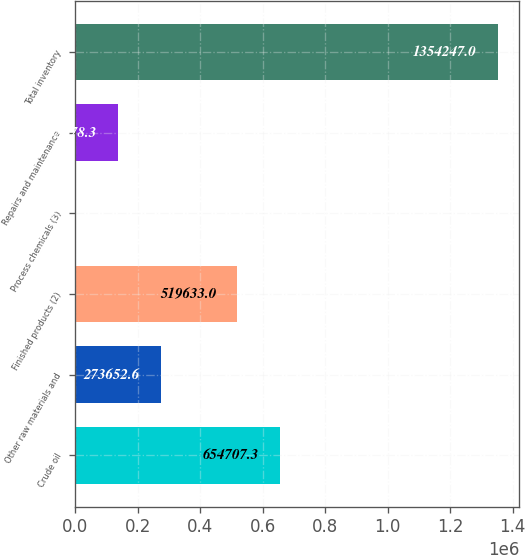Convert chart to OTSL. <chart><loc_0><loc_0><loc_500><loc_500><bar_chart><fcel>Crude oil<fcel>Other raw materials and<fcel>Finished products (2)<fcel>Process chemicals (3)<fcel>Repairs and maintenance<fcel>Total inventory<nl><fcel>654707<fcel>273653<fcel>519633<fcel>3504<fcel>138578<fcel>1.35425e+06<nl></chart> 